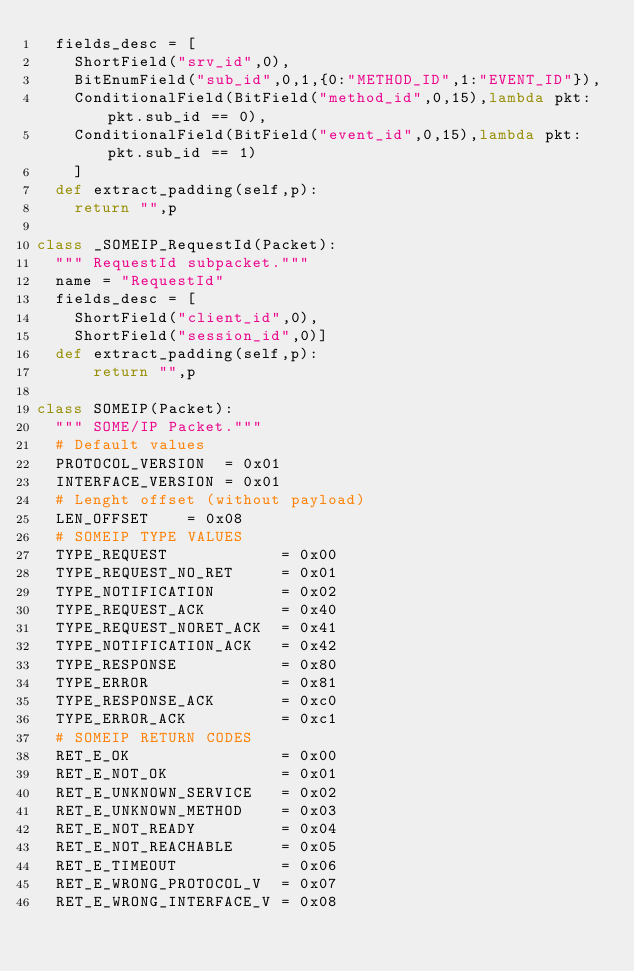<code> <loc_0><loc_0><loc_500><loc_500><_Python_>  fields_desc = [ 
    ShortField("srv_id",0),
    BitEnumField("sub_id",0,1,{0:"METHOD_ID",1:"EVENT_ID"}),
    ConditionalField(BitField("method_id",0,15),lambda pkt:pkt.sub_id == 0),
    ConditionalField(BitField("event_id",0,15),lambda pkt:pkt.sub_id == 1)
    ]
  def extract_padding(self,p):
    return "",p

class _SOMEIP_RequestId(Packet):
  """ RequestId subpacket."""
  name = "RequestId"
  fields_desc = [ 
    ShortField("client_id",0),
    ShortField("session_id",0)]
  def extract_padding(self,p):
      return "",p

class SOMEIP(Packet):
  """ SOME/IP Packet."""
  # Default values
  PROTOCOL_VERSION  = 0x01
  INTERFACE_VERSION = 0x01
  # Lenght offset (without payload)
  LEN_OFFSET    = 0x08
  # SOMEIP TYPE VALUES
  TYPE_REQUEST            = 0x00
  TYPE_REQUEST_NO_RET     = 0x01
  TYPE_NOTIFICATION       = 0x02
  TYPE_REQUEST_ACK        = 0x40
  TYPE_REQUEST_NORET_ACK  = 0x41 
  TYPE_NOTIFICATION_ACK   = 0x42
  TYPE_RESPONSE           = 0x80
  TYPE_ERROR              = 0x81
  TYPE_RESPONSE_ACK       = 0xc0
  TYPE_ERROR_ACK          = 0xc1
  # SOMEIP RETURN CODES
  RET_E_OK                = 0x00
  RET_E_NOT_OK            = 0x01
  RET_E_UNKNOWN_SERVICE   = 0x02
  RET_E_UNKNOWN_METHOD    = 0x03
  RET_E_NOT_READY         = 0x04
  RET_E_NOT_REACHABLE     = 0x05
  RET_E_TIMEOUT           = 0x06
  RET_E_WRONG_PROTOCOL_V  = 0x07
  RET_E_WRONG_INTERFACE_V = 0x08</code> 